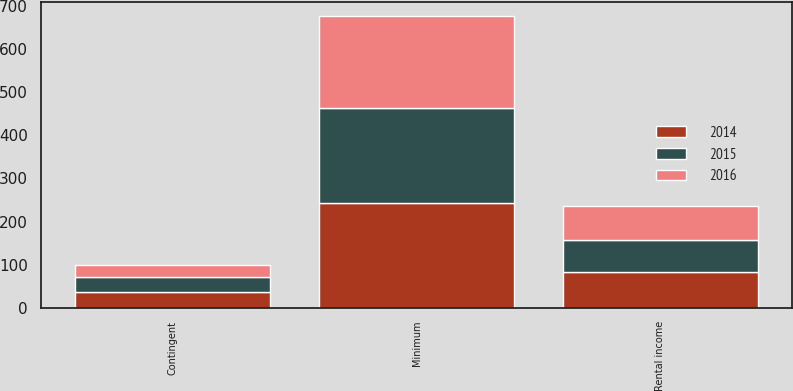Convert chart to OTSL. <chart><loc_0><loc_0><loc_500><loc_500><stacked_bar_chart><ecel><fcel>Minimum<fcel>Contingent<fcel>Rental income<nl><fcel>2016<fcel>213<fcel>29<fcel>79<nl><fcel>2015<fcel>221<fcel>34<fcel>73<nl><fcel>2014<fcel>243<fcel>37<fcel>83<nl></chart> 